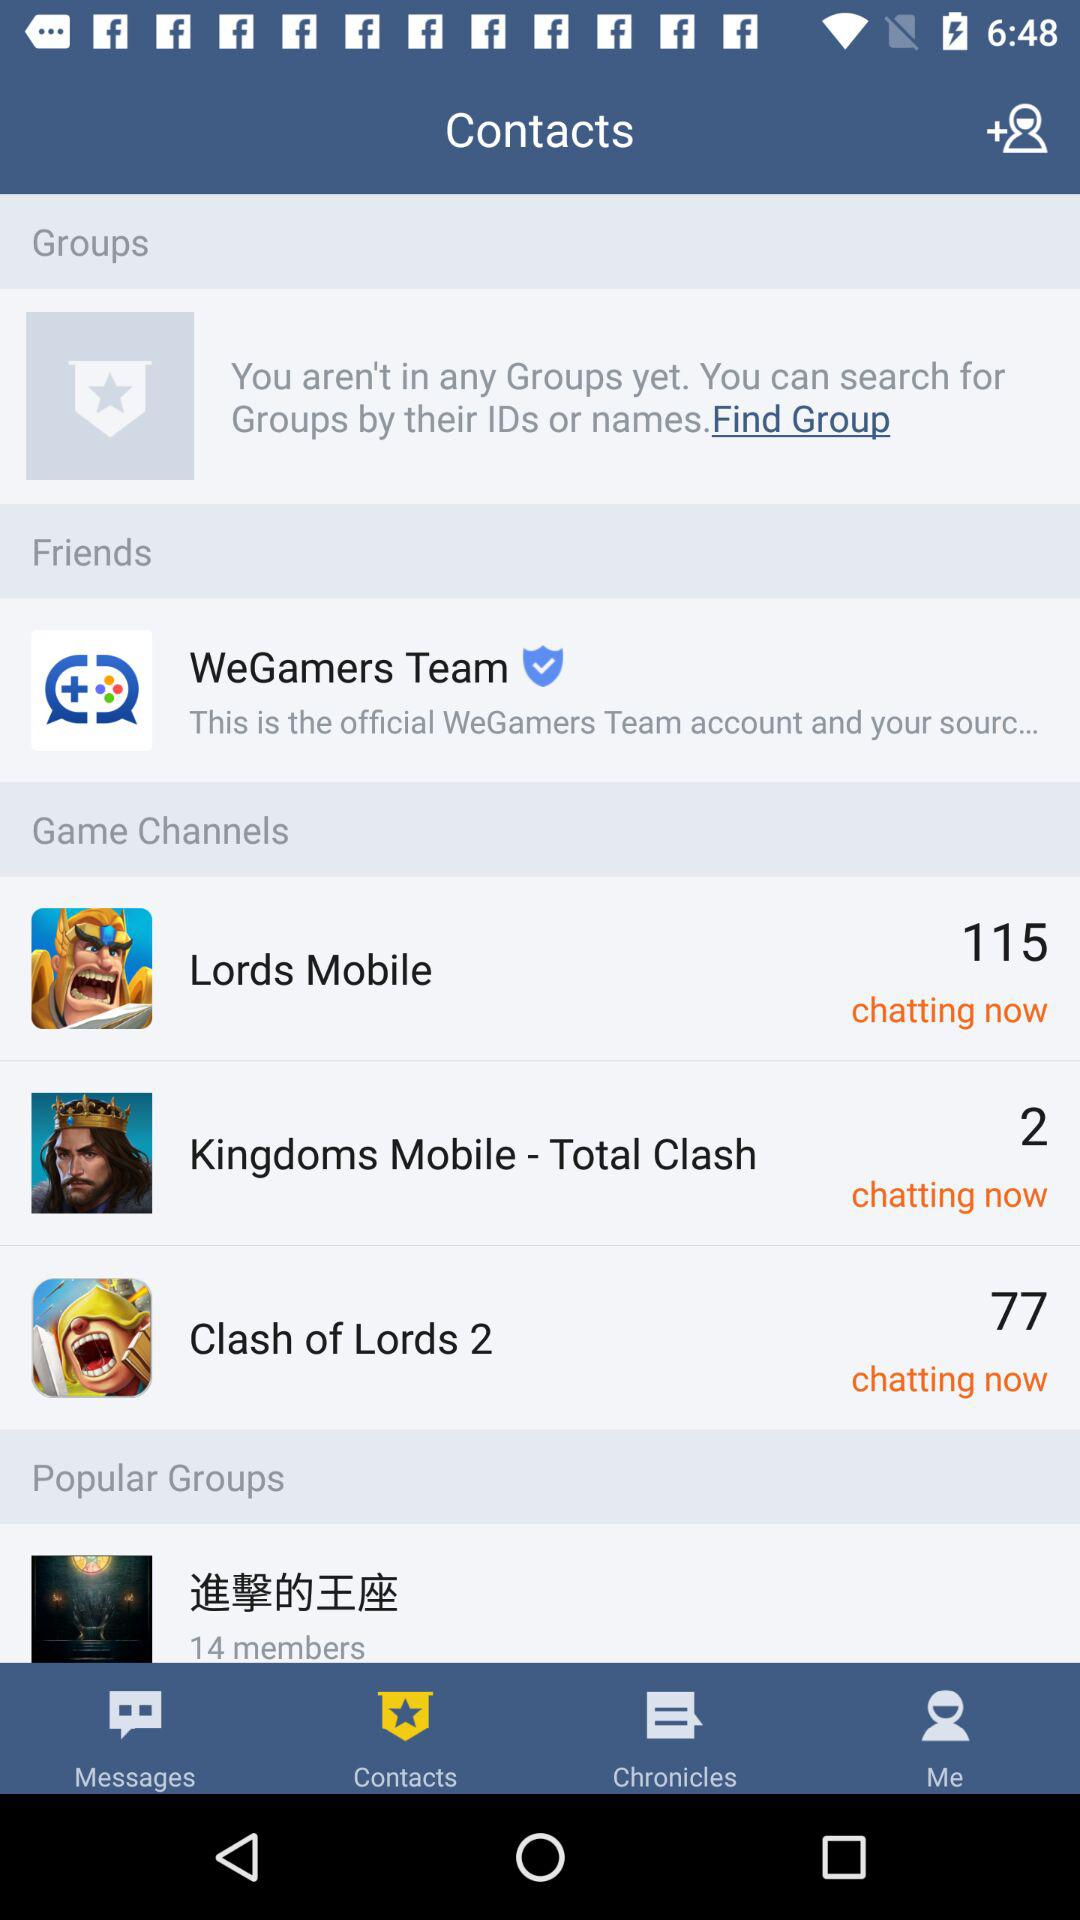Which game has 77 chats available? The game is "Clash of Lords 2". 